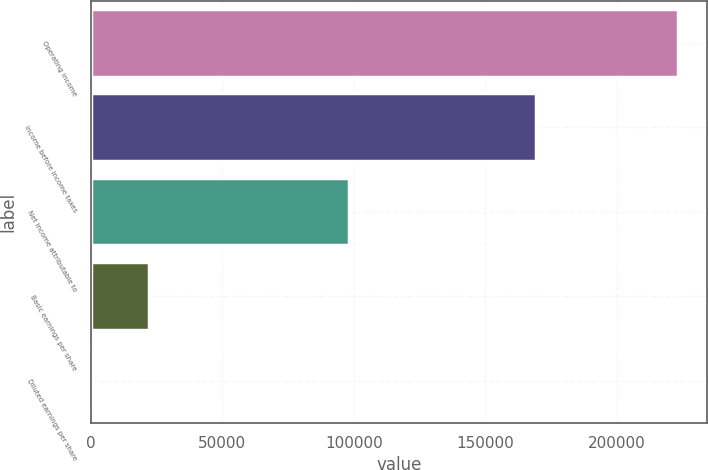<chart> <loc_0><loc_0><loc_500><loc_500><bar_chart><fcel>Operating income<fcel>Income before income taxes<fcel>Net income attributable to<fcel>Basic earnings per share<fcel>Diluted earnings per share<nl><fcel>223109<fcel>169364<fcel>98365<fcel>22311.8<fcel>0.94<nl></chart> 